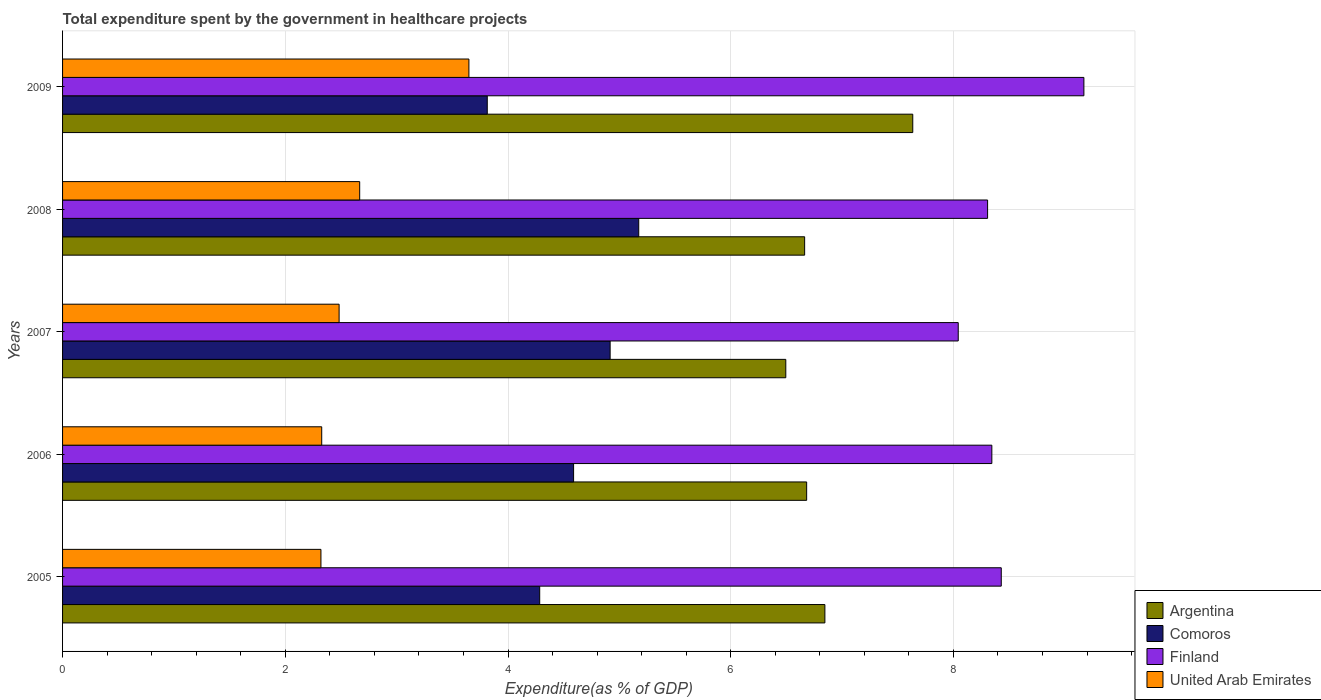How many different coloured bars are there?
Offer a very short reply. 4. How many groups of bars are there?
Offer a very short reply. 5. Are the number of bars per tick equal to the number of legend labels?
Your answer should be compact. Yes. Are the number of bars on each tick of the Y-axis equal?
Your response must be concise. Yes. What is the label of the 5th group of bars from the top?
Your answer should be very brief. 2005. What is the total expenditure spent by the government in healthcare projects in United Arab Emirates in 2006?
Your answer should be compact. 2.33. Across all years, what is the maximum total expenditure spent by the government in healthcare projects in Argentina?
Give a very brief answer. 7.63. Across all years, what is the minimum total expenditure spent by the government in healthcare projects in Comoros?
Make the answer very short. 3.81. In which year was the total expenditure spent by the government in healthcare projects in Finland minimum?
Keep it short and to the point. 2007. What is the total total expenditure spent by the government in healthcare projects in Argentina in the graph?
Give a very brief answer. 34.32. What is the difference between the total expenditure spent by the government in healthcare projects in United Arab Emirates in 2005 and that in 2008?
Offer a terse response. -0.35. What is the difference between the total expenditure spent by the government in healthcare projects in Argentina in 2009 and the total expenditure spent by the government in healthcare projects in United Arab Emirates in 2008?
Provide a succinct answer. 4.97. What is the average total expenditure spent by the government in healthcare projects in Comoros per year?
Provide a succinct answer. 4.56. In the year 2005, what is the difference between the total expenditure spent by the government in healthcare projects in Finland and total expenditure spent by the government in healthcare projects in Comoros?
Make the answer very short. 4.14. What is the ratio of the total expenditure spent by the government in healthcare projects in Finland in 2005 to that in 2008?
Offer a very short reply. 1.01. Is the total expenditure spent by the government in healthcare projects in Argentina in 2005 less than that in 2009?
Offer a very short reply. Yes. What is the difference between the highest and the second highest total expenditure spent by the government in healthcare projects in Argentina?
Your answer should be very brief. 0.79. What is the difference between the highest and the lowest total expenditure spent by the government in healthcare projects in Argentina?
Make the answer very short. 1.14. Is the sum of the total expenditure spent by the government in healthcare projects in Argentina in 2007 and 2008 greater than the maximum total expenditure spent by the government in healthcare projects in Comoros across all years?
Your response must be concise. Yes. Is it the case that in every year, the sum of the total expenditure spent by the government in healthcare projects in United Arab Emirates and total expenditure spent by the government in healthcare projects in Argentina is greater than the sum of total expenditure spent by the government in healthcare projects in Finland and total expenditure spent by the government in healthcare projects in Comoros?
Make the answer very short. Yes. Is it the case that in every year, the sum of the total expenditure spent by the government in healthcare projects in Argentina and total expenditure spent by the government in healthcare projects in Finland is greater than the total expenditure spent by the government in healthcare projects in Comoros?
Provide a succinct answer. Yes. How many years are there in the graph?
Give a very brief answer. 5. What is the difference between two consecutive major ticks on the X-axis?
Keep it short and to the point. 2. Are the values on the major ticks of X-axis written in scientific E-notation?
Your response must be concise. No. Does the graph contain grids?
Your answer should be compact. Yes. Where does the legend appear in the graph?
Keep it short and to the point. Bottom right. How many legend labels are there?
Offer a very short reply. 4. How are the legend labels stacked?
Your answer should be very brief. Vertical. What is the title of the graph?
Your answer should be very brief. Total expenditure spent by the government in healthcare projects. What is the label or title of the X-axis?
Provide a short and direct response. Expenditure(as % of GDP). What is the Expenditure(as % of GDP) in Argentina in 2005?
Your answer should be very brief. 6.85. What is the Expenditure(as % of GDP) of Comoros in 2005?
Keep it short and to the point. 4.28. What is the Expenditure(as % of GDP) in Finland in 2005?
Offer a terse response. 8.43. What is the Expenditure(as % of GDP) of United Arab Emirates in 2005?
Make the answer very short. 2.32. What is the Expenditure(as % of GDP) of Argentina in 2006?
Ensure brevity in your answer.  6.68. What is the Expenditure(as % of GDP) of Comoros in 2006?
Offer a very short reply. 4.59. What is the Expenditure(as % of GDP) in Finland in 2006?
Provide a succinct answer. 8.34. What is the Expenditure(as % of GDP) of United Arab Emirates in 2006?
Make the answer very short. 2.33. What is the Expenditure(as % of GDP) in Argentina in 2007?
Offer a terse response. 6.49. What is the Expenditure(as % of GDP) in Comoros in 2007?
Your response must be concise. 4.92. What is the Expenditure(as % of GDP) of Finland in 2007?
Provide a short and direct response. 8.04. What is the Expenditure(as % of GDP) of United Arab Emirates in 2007?
Provide a succinct answer. 2.48. What is the Expenditure(as % of GDP) in Argentina in 2008?
Your answer should be very brief. 6.66. What is the Expenditure(as % of GDP) of Comoros in 2008?
Offer a very short reply. 5.17. What is the Expenditure(as % of GDP) in Finland in 2008?
Offer a terse response. 8.31. What is the Expenditure(as % of GDP) of United Arab Emirates in 2008?
Make the answer very short. 2.67. What is the Expenditure(as % of GDP) in Argentina in 2009?
Your response must be concise. 7.63. What is the Expenditure(as % of GDP) in Comoros in 2009?
Provide a succinct answer. 3.81. What is the Expenditure(as % of GDP) of Finland in 2009?
Make the answer very short. 9.17. What is the Expenditure(as % of GDP) in United Arab Emirates in 2009?
Keep it short and to the point. 3.65. Across all years, what is the maximum Expenditure(as % of GDP) of Argentina?
Your answer should be very brief. 7.63. Across all years, what is the maximum Expenditure(as % of GDP) in Comoros?
Give a very brief answer. 5.17. Across all years, what is the maximum Expenditure(as % of GDP) in Finland?
Your response must be concise. 9.17. Across all years, what is the maximum Expenditure(as % of GDP) in United Arab Emirates?
Provide a succinct answer. 3.65. Across all years, what is the minimum Expenditure(as % of GDP) in Argentina?
Provide a short and direct response. 6.49. Across all years, what is the minimum Expenditure(as % of GDP) in Comoros?
Offer a very short reply. 3.81. Across all years, what is the minimum Expenditure(as % of GDP) of Finland?
Offer a terse response. 8.04. Across all years, what is the minimum Expenditure(as % of GDP) of United Arab Emirates?
Provide a short and direct response. 2.32. What is the total Expenditure(as % of GDP) of Argentina in the graph?
Make the answer very short. 34.32. What is the total Expenditure(as % of GDP) of Comoros in the graph?
Your answer should be very brief. 22.78. What is the total Expenditure(as % of GDP) of Finland in the graph?
Offer a terse response. 42.3. What is the total Expenditure(as % of GDP) in United Arab Emirates in the graph?
Offer a very short reply. 13.45. What is the difference between the Expenditure(as % of GDP) in Argentina in 2005 and that in 2006?
Provide a succinct answer. 0.16. What is the difference between the Expenditure(as % of GDP) of Comoros in 2005 and that in 2006?
Your response must be concise. -0.3. What is the difference between the Expenditure(as % of GDP) in Finland in 2005 and that in 2006?
Make the answer very short. 0.08. What is the difference between the Expenditure(as % of GDP) of United Arab Emirates in 2005 and that in 2006?
Offer a very short reply. -0.01. What is the difference between the Expenditure(as % of GDP) of Argentina in 2005 and that in 2007?
Your response must be concise. 0.35. What is the difference between the Expenditure(as % of GDP) in Comoros in 2005 and that in 2007?
Make the answer very short. -0.63. What is the difference between the Expenditure(as % of GDP) in Finland in 2005 and that in 2007?
Ensure brevity in your answer.  0.39. What is the difference between the Expenditure(as % of GDP) in United Arab Emirates in 2005 and that in 2007?
Your response must be concise. -0.16. What is the difference between the Expenditure(as % of GDP) of Argentina in 2005 and that in 2008?
Offer a terse response. 0.18. What is the difference between the Expenditure(as % of GDP) of Comoros in 2005 and that in 2008?
Give a very brief answer. -0.89. What is the difference between the Expenditure(as % of GDP) in Finland in 2005 and that in 2008?
Your response must be concise. 0.12. What is the difference between the Expenditure(as % of GDP) of United Arab Emirates in 2005 and that in 2008?
Your answer should be very brief. -0.35. What is the difference between the Expenditure(as % of GDP) of Argentina in 2005 and that in 2009?
Your answer should be compact. -0.79. What is the difference between the Expenditure(as % of GDP) in Comoros in 2005 and that in 2009?
Give a very brief answer. 0.47. What is the difference between the Expenditure(as % of GDP) of Finland in 2005 and that in 2009?
Give a very brief answer. -0.74. What is the difference between the Expenditure(as % of GDP) in United Arab Emirates in 2005 and that in 2009?
Offer a terse response. -1.33. What is the difference between the Expenditure(as % of GDP) of Argentina in 2006 and that in 2007?
Ensure brevity in your answer.  0.19. What is the difference between the Expenditure(as % of GDP) in Comoros in 2006 and that in 2007?
Ensure brevity in your answer.  -0.33. What is the difference between the Expenditure(as % of GDP) in Finland in 2006 and that in 2007?
Provide a short and direct response. 0.3. What is the difference between the Expenditure(as % of GDP) in United Arab Emirates in 2006 and that in 2007?
Your answer should be very brief. -0.16. What is the difference between the Expenditure(as % of GDP) in Argentina in 2006 and that in 2008?
Provide a succinct answer. 0.02. What is the difference between the Expenditure(as % of GDP) of Comoros in 2006 and that in 2008?
Your answer should be very brief. -0.58. What is the difference between the Expenditure(as % of GDP) of Finland in 2006 and that in 2008?
Provide a succinct answer. 0.04. What is the difference between the Expenditure(as % of GDP) of United Arab Emirates in 2006 and that in 2008?
Your answer should be compact. -0.34. What is the difference between the Expenditure(as % of GDP) in Argentina in 2006 and that in 2009?
Offer a very short reply. -0.95. What is the difference between the Expenditure(as % of GDP) of Comoros in 2006 and that in 2009?
Keep it short and to the point. 0.78. What is the difference between the Expenditure(as % of GDP) of Finland in 2006 and that in 2009?
Make the answer very short. -0.83. What is the difference between the Expenditure(as % of GDP) of United Arab Emirates in 2006 and that in 2009?
Give a very brief answer. -1.32. What is the difference between the Expenditure(as % of GDP) of Argentina in 2007 and that in 2008?
Keep it short and to the point. -0.17. What is the difference between the Expenditure(as % of GDP) in Comoros in 2007 and that in 2008?
Offer a very short reply. -0.26. What is the difference between the Expenditure(as % of GDP) in Finland in 2007 and that in 2008?
Provide a short and direct response. -0.26. What is the difference between the Expenditure(as % of GDP) in United Arab Emirates in 2007 and that in 2008?
Keep it short and to the point. -0.18. What is the difference between the Expenditure(as % of GDP) in Argentina in 2007 and that in 2009?
Your response must be concise. -1.14. What is the difference between the Expenditure(as % of GDP) in Comoros in 2007 and that in 2009?
Provide a succinct answer. 1.1. What is the difference between the Expenditure(as % of GDP) in Finland in 2007 and that in 2009?
Your answer should be compact. -1.13. What is the difference between the Expenditure(as % of GDP) of United Arab Emirates in 2007 and that in 2009?
Offer a terse response. -1.17. What is the difference between the Expenditure(as % of GDP) of Argentina in 2008 and that in 2009?
Give a very brief answer. -0.97. What is the difference between the Expenditure(as % of GDP) in Comoros in 2008 and that in 2009?
Ensure brevity in your answer.  1.36. What is the difference between the Expenditure(as % of GDP) in Finland in 2008 and that in 2009?
Provide a succinct answer. -0.86. What is the difference between the Expenditure(as % of GDP) in United Arab Emirates in 2008 and that in 2009?
Keep it short and to the point. -0.98. What is the difference between the Expenditure(as % of GDP) in Argentina in 2005 and the Expenditure(as % of GDP) in Comoros in 2006?
Ensure brevity in your answer.  2.26. What is the difference between the Expenditure(as % of GDP) of Argentina in 2005 and the Expenditure(as % of GDP) of Finland in 2006?
Give a very brief answer. -1.5. What is the difference between the Expenditure(as % of GDP) of Argentina in 2005 and the Expenditure(as % of GDP) of United Arab Emirates in 2006?
Keep it short and to the point. 4.52. What is the difference between the Expenditure(as % of GDP) of Comoros in 2005 and the Expenditure(as % of GDP) of Finland in 2006?
Your response must be concise. -4.06. What is the difference between the Expenditure(as % of GDP) in Comoros in 2005 and the Expenditure(as % of GDP) in United Arab Emirates in 2006?
Keep it short and to the point. 1.96. What is the difference between the Expenditure(as % of GDP) in Finland in 2005 and the Expenditure(as % of GDP) in United Arab Emirates in 2006?
Your response must be concise. 6.1. What is the difference between the Expenditure(as % of GDP) of Argentina in 2005 and the Expenditure(as % of GDP) of Comoros in 2007?
Ensure brevity in your answer.  1.93. What is the difference between the Expenditure(as % of GDP) of Argentina in 2005 and the Expenditure(as % of GDP) of Finland in 2007?
Give a very brief answer. -1.2. What is the difference between the Expenditure(as % of GDP) of Argentina in 2005 and the Expenditure(as % of GDP) of United Arab Emirates in 2007?
Ensure brevity in your answer.  4.36. What is the difference between the Expenditure(as % of GDP) in Comoros in 2005 and the Expenditure(as % of GDP) in Finland in 2007?
Ensure brevity in your answer.  -3.76. What is the difference between the Expenditure(as % of GDP) of Comoros in 2005 and the Expenditure(as % of GDP) of United Arab Emirates in 2007?
Your answer should be very brief. 1.8. What is the difference between the Expenditure(as % of GDP) in Finland in 2005 and the Expenditure(as % of GDP) in United Arab Emirates in 2007?
Provide a short and direct response. 5.95. What is the difference between the Expenditure(as % of GDP) in Argentina in 2005 and the Expenditure(as % of GDP) in Comoros in 2008?
Provide a succinct answer. 1.67. What is the difference between the Expenditure(as % of GDP) in Argentina in 2005 and the Expenditure(as % of GDP) in Finland in 2008?
Make the answer very short. -1.46. What is the difference between the Expenditure(as % of GDP) in Argentina in 2005 and the Expenditure(as % of GDP) in United Arab Emirates in 2008?
Provide a succinct answer. 4.18. What is the difference between the Expenditure(as % of GDP) of Comoros in 2005 and the Expenditure(as % of GDP) of Finland in 2008?
Offer a very short reply. -4.02. What is the difference between the Expenditure(as % of GDP) in Comoros in 2005 and the Expenditure(as % of GDP) in United Arab Emirates in 2008?
Offer a terse response. 1.62. What is the difference between the Expenditure(as % of GDP) of Finland in 2005 and the Expenditure(as % of GDP) of United Arab Emirates in 2008?
Give a very brief answer. 5.76. What is the difference between the Expenditure(as % of GDP) in Argentina in 2005 and the Expenditure(as % of GDP) in Comoros in 2009?
Provide a short and direct response. 3.03. What is the difference between the Expenditure(as % of GDP) of Argentina in 2005 and the Expenditure(as % of GDP) of Finland in 2009?
Your response must be concise. -2.33. What is the difference between the Expenditure(as % of GDP) in Argentina in 2005 and the Expenditure(as % of GDP) in United Arab Emirates in 2009?
Your answer should be very brief. 3.2. What is the difference between the Expenditure(as % of GDP) in Comoros in 2005 and the Expenditure(as % of GDP) in Finland in 2009?
Provide a short and direct response. -4.89. What is the difference between the Expenditure(as % of GDP) in Comoros in 2005 and the Expenditure(as % of GDP) in United Arab Emirates in 2009?
Your answer should be very brief. 0.64. What is the difference between the Expenditure(as % of GDP) in Finland in 2005 and the Expenditure(as % of GDP) in United Arab Emirates in 2009?
Ensure brevity in your answer.  4.78. What is the difference between the Expenditure(as % of GDP) of Argentina in 2006 and the Expenditure(as % of GDP) of Comoros in 2007?
Your answer should be compact. 1.76. What is the difference between the Expenditure(as % of GDP) in Argentina in 2006 and the Expenditure(as % of GDP) in Finland in 2007?
Give a very brief answer. -1.36. What is the difference between the Expenditure(as % of GDP) of Argentina in 2006 and the Expenditure(as % of GDP) of United Arab Emirates in 2007?
Give a very brief answer. 4.2. What is the difference between the Expenditure(as % of GDP) of Comoros in 2006 and the Expenditure(as % of GDP) of Finland in 2007?
Give a very brief answer. -3.45. What is the difference between the Expenditure(as % of GDP) of Comoros in 2006 and the Expenditure(as % of GDP) of United Arab Emirates in 2007?
Your answer should be compact. 2.11. What is the difference between the Expenditure(as % of GDP) of Finland in 2006 and the Expenditure(as % of GDP) of United Arab Emirates in 2007?
Your response must be concise. 5.86. What is the difference between the Expenditure(as % of GDP) of Argentina in 2006 and the Expenditure(as % of GDP) of Comoros in 2008?
Offer a terse response. 1.51. What is the difference between the Expenditure(as % of GDP) of Argentina in 2006 and the Expenditure(as % of GDP) of Finland in 2008?
Your answer should be compact. -1.62. What is the difference between the Expenditure(as % of GDP) in Argentina in 2006 and the Expenditure(as % of GDP) in United Arab Emirates in 2008?
Offer a very short reply. 4.01. What is the difference between the Expenditure(as % of GDP) in Comoros in 2006 and the Expenditure(as % of GDP) in Finland in 2008?
Your answer should be compact. -3.72. What is the difference between the Expenditure(as % of GDP) of Comoros in 2006 and the Expenditure(as % of GDP) of United Arab Emirates in 2008?
Give a very brief answer. 1.92. What is the difference between the Expenditure(as % of GDP) of Finland in 2006 and the Expenditure(as % of GDP) of United Arab Emirates in 2008?
Ensure brevity in your answer.  5.68. What is the difference between the Expenditure(as % of GDP) in Argentina in 2006 and the Expenditure(as % of GDP) in Comoros in 2009?
Provide a short and direct response. 2.87. What is the difference between the Expenditure(as % of GDP) in Argentina in 2006 and the Expenditure(as % of GDP) in Finland in 2009?
Your response must be concise. -2.49. What is the difference between the Expenditure(as % of GDP) in Argentina in 2006 and the Expenditure(as % of GDP) in United Arab Emirates in 2009?
Make the answer very short. 3.03. What is the difference between the Expenditure(as % of GDP) in Comoros in 2006 and the Expenditure(as % of GDP) in Finland in 2009?
Offer a very short reply. -4.58. What is the difference between the Expenditure(as % of GDP) in Comoros in 2006 and the Expenditure(as % of GDP) in United Arab Emirates in 2009?
Offer a very short reply. 0.94. What is the difference between the Expenditure(as % of GDP) in Finland in 2006 and the Expenditure(as % of GDP) in United Arab Emirates in 2009?
Provide a succinct answer. 4.7. What is the difference between the Expenditure(as % of GDP) in Argentina in 2007 and the Expenditure(as % of GDP) in Comoros in 2008?
Make the answer very short. 1.32. What is the difference between the Expenditure(as % of GDP) in Argentina in 2007 and the Expenditure(as % of GDP) in Finland in 2008?
Your response must be concise. -1.81. What is the difference between the Expenditure(as % of GDP) in Argentina in 2007 and the Expenditure(as % of GDP) in United Arab Emirates in 2008?
Your answer should be compact. 3.83. What is the difference between the Expenditure(as % of GDP) of Comoros in 2007 and the Expenditure(as % of GDP) of Finland in 2008?
Your answer should be compact. -3.39. What is the difference between the Expenditure(as % of GDP) in Comoros in 2007 and the Expenditure(as % of GDP) in United Arab Emirates in 2008?
Offer a terse response. 2.25. What is the difference between the Expenditure(as % of GDP) in Finland in 2007 and the Expenditure(as % of GDP) in United Arab Emirates in 2008?
Your answer should be very brief. 5.37. What is the difference between the Expenditure(as % of GDP) of Argentina in 2007 and the Expenditure(as % of GDP) of Comoros in 2009?
Keep it short and to the point. 2.68. What is the difference between the Expenditure(as % of GDP) in Argentina in 2007 and the Expenditure(as % of GDP) in Finland in 2009?
Ensure brevity in your answer.  -2.68. What is the difference between the Expenditure(as % of GDP) in Argentina in 2007 and the Expenditure(as % of GDP) in United Arab Emirates in 2009?
Your answer should be compact. 2.85. What is the difference between the Expenditure(as % of GDP) in Comoros in 2007 and the Expenditure(as % of GDP) in Finland in 2009?
Keep it short and to the point. -4.25. What is the difference between the Expenditure(as % of GDP) in Comoros in 2007 and the Expenditure(as % of GDP) in United Arab Emirates in 2009?
Offer a terse response. 1.27. What is the difference between the Expenditure(as % of GDP) in Finland in 2007 and the Expenditure(as % of GDP) in United Arab Emirates in 2009?
Your answer should be compact. 4.39. What is the difference between the Expenditure(as % of GDP) in Argentina in 2008 and the Expenditure(as % of GDP) in Comoros in 2009?
Provide a short and direct response. 2.85. What is the difference between the Expenditure(as % of GDP) of Argentina in 2008 and the Expenditure(as % of GDP) of Finland in 2009?
Keep it short and to the point. -2.51. What is the difference between the Expenditure(as % of GDP) of Argentina in 2008 and the Expenditure(as % of GDP) of United Arab Emirates in 2009?
Your answer should be very brief. 3.01. What is the difference between the Expenditure(as % of GDP) in Comoros in 2008 and the Expenditure(as % of GDP) in Finland in 2009?
Your answer should be compact. -4. What is the difference between the Expenditure(as % of GDP) in Comoros in 2008 and the Expenditure(as % of GDP) in United Arab Emirates in 2009?
Offer a terse response. 1.53. What is the difference between the Expenditure(as % of GDP) in Finland in 2008 and the Expenditure(as % of GDP) in United Arab Emirates in 2009?
Ensure brevity in your answer.  4.66. What is the average Expenditure(as % of GDP) of Argentina per year?
Your answer should be very brief. 6.86. What is the average Expenditure(as % of GDP) in Comoros per year?
Offer a very short reply. 4.56. What is the average Expenditure(as % of GDP) of Finland per year?
Give a very brief answer. 8.46. What is the average Expenditure(as % of GDP) of United Arab Emirates per year?
Offer a very short reply. 2.69. In the year 2005, what is the difference between the Expenditure(as % of GDP) in Argentina and Expenditure(as % of GDP) in Comoros?
Your answer should be very brief. 2.56. In the year 2005, what is the difference between the Expenditure(as % of GDP) of Argentina and Expenditure(as % of GDP) of Finland?
Make the answer very short. -1.58. In the year 2005, what is the difference between the Expenditure(as % of GDP) of Argentina and Expenditure(as % of GDP) of United Arab Emirates?
Give a very brief answer. 4.53. In the year 2005, what is the difference between the Expenditure(as % of GDP) of Comoros and Expenditure(as % of GDP) of Finland?
Keep it short and to the point. -4.14. In the year 2005, what is the difference between the Expenditure(as % of GDP) of Comoros and Expenditure(as % of GDP) of United Arab Emirates?
Offer a terse response. 1.96. In the year 2005, what is the difference between the Expenditure(as % of GDP) of Finland and Expenditure(as % of GDP) of United Arab Emirates?
Offer a terse response. 6.11. In the year 2006, what is the difference between the Expenditure(as % of GDP) in Argentina and Expenditure(as % of GDP) in Comoros?
Make the answer very short. 2.09. In the year 2006, what is the difference between the Expenditure(as % of GDP) in Argentina and Expenditure(as % of GDP) in Finland?
Your answer should be compact. -1.66. In the year 2006, what is the difference between the Expenditure(as % of GDP) of Argentina and Expenditure(as % of GDP) of United Arab Emirates?
Make the answer very short. 4.35. In the year 2006, what is the difference between the Expenditure(as % of GDP) of Comoros and Expenditure(as % of GDP) of Finland?
Provide a short and direct response. -3.76. In the year 2006, what is the difference between the Expenditure(as % of GDP) in Comoros and Expenditure(as % of GDP) in United Arab Emirates?
Offer a very short reply. 2.26. In the year 2006, what is the difference between the Expenditure(as % of GDP) in Finland and Expenditure(as % of GDP) in United Arab Emirates?
Your answer should be very brief. 6.02. In the year 2007, what is the difference between the Expenditure(as % of GDP) in Argentina and Expenditure(as % of GDP) in Comoros?
Your response must be concise. 1.58. In the year 2007, what is the difference between the Expenditure(as % of GDP) in Argentina and Expenditure(as % of GDP) in Finland?
Offer a terse response. -1.55. In the year 2007, what is the difference between the Expenditure(as % of GDP) of Argentina and Expenditure(as % of GDP) of United Arab Emirates?
Give a very brief answer. 4.01. In the year 2007, what is the difference between the Expenditure(as % of GDP) in Comoros and Expenditure(as % of GDP) in Finland?
Provide a succinct answer. -3.13. In the year 2007, what is the difference between the Expenditure(as % of GDP) of Comoros and Expenditure(as % of GDP) of United Arab Emirates?
Make the answer very short. 2.43. In the year 2007, what is the difference between the Expenditure(as % of GDP) of Finland and Expenditure(as % of GDP) of United Arab Emirates?
Ensure brevity in your answer.  5.56. In the year 2008, what is the difference between the Expenditure(as % of GDP) in Argentina and Expenditure(as % of GDP) in Comoros?
Give a very brief answer. 1.49. In the year 2008, what is the difference between the Expenditure(as % of GDP) of Argentina and Expenditure(as % of GDP) of Finland?
Your answer should be compact. -1.64. In the year 2008, what is the difference between the Expenditure(as % of GDP) of Argentina and Expenditure(as % of GDP) of United Arab Emirates?
Offer a terse response. 4. In the year 2008, what is the difference between the Expenditure(as % of GDP) of Comoros and Expenditure(as % of GDP) of Finland?
Make the answer very short. -3.13. In the year 2008, what is the difference between the Expenditure(as % of GDP) of Comoros and Expenditure(as % of GDP) of United Arab Emirates?
Your answer should be very brief. 2.51. In the year 2008, what is the difference between the Expenditure(as % of GDP) in Finland and Expenditure(as % of GDP) in United Arab Emirates?
Provide a short and direct response. 5.64. In the year 2009, what is the difference between the Expenditure(as % of GDP) in Argentina and Expenditure(as % of GDP) in Comoros?
Your answer should be very brief. 3.82. In the year 2009, what is the difference between the Expenditure(as % of GDP) in Argentina and Expenditure(as % of GDP) in Finland?
Offer a very short reply. -1.54. In the year 2009, what is the difference between the Expenditure(as % of GDP) in Argentina and Expenditure(as % of GDP) in United Arab Emirates?
Provide a succinct answer. 3.99. In the year 2009, what is the difference between the Expenditure(as % of GDP) of Comoros and Expenditure(as % of GDP) of Finland?
Provide a short and direct response. -5.36. In the year 2009, what is the difference between the Expenditure(as % of GDP) in Comoros and Expenditure(as % of GDP) in United Arab Emirates?
Offer a terse response. 0.17. In the year 2009, what is the difference between the Expenditure(as % of GDP) in Finland and Expenditure(as % of GDP) in United Arab Emirates?
Your answer should be compact. 5.52. What is the ratio of the Expenditure(as % of GDP) in Argentina in 2005 to that in 2006?
Provide a short and direct response. 1.02. What is the ratio of the Expenditure(as % of GDP) in Comoros in 2005 to that in 2006?
Offer a very short reply. 0.93. What is the ratio of the Expenditure(as % of GDP) of Argentina in 2005 to that in 2007?
Your answer should be compact. 1.05. What is the ratio of the Expenditure(as % of GDP) in Comoros in 2005 to that in 2007?
Offer a terse response. 0.87. What is the ratio of the Expenditure(as % of GDP) of Finland in 2005 to that in 2007?
Ensure brevity in your answer.  1.05. What is the ratio of the Expenditure(as % of GDP) of United Arab Emirates in 2005 to that in 2007?
Offer a terse response. 0.93. What is the ratio of the Expenditure(as % of GDP) of Argentina in 2005 to that in 2008?
Your answer should be compact. 1.03. What is the ratio of the Expenditure(as % of GDP) in Comoros in 2005 to that in 2008?
Your response must be concise. 0.83. What is the ratio of the Expenditure(as % of GDP) in Finland in 2005 to that in 2008?
Keep it short and to the point. 1.01. What is the ratio of the Expenditure(as % of GDP) in United Arab Emirates in 2005 to that in 2008?
Ensure brevity in your answer.  0.87. What is the ratio of the Expenditure(as % of GDP) of Argentina in 2005 to that in 2009?
Keep it short and to the point. 0.9. What is the ratio of the Expenditure(as % of GDP) of Comoros in 2005 to that in 2009?
Keep it short and to the point. 1.12. What is the ratio of the Expenditure(as % of GDP) of Finland in 2005 to that in 2009?
Your answer should be compact. 0.92. What is the ratio of the Expenditure(as % of GDP) of United Arab Emirates in 2005 to that in 2009?
Provide a succinct answer. 0.64. What is the ratio of the Expenditure(as % of GDP) of Argentina in 2006 to that in 2007?
Your answer should be compact. 1.03. What is the ratio of the Expenditure(as % of GDP) in Comoros in 2006 to that in 2007?
Offer a terse response. 0.93. What is the ratio of the Expenditure(as % of GDP) of Finland in 2006 to that in 2007?
Give a very brief answer. 1.04. What is the ratio of the Expenditure(as % of GDP) of United Arab Emirates in 2006 to that in 2007?
Keep it short and to the point. 0.94. What is the ratio of the Expenditure(as % of GDP) of Argentina in 2006 to that in 2008?
Your answer should be very brief. 1. What is the ratio of the Expenditure(as % of GDP) of Comoros in 2006 to that in 2008?
Provide a short and direct response. 0.89. What is the ratio of the Expenditure(as % of GDP) in United Arab Emirates in 2006 to that in 2008?
Provide a succinct answer. 0.87. What is the ratio of the Expenditure(as % of GDP) in Argentina in 2006 to that in 2009?
Offer a very short reply. 0.88. What is the ratio of the Expenditure(as % of GDP) in Comoros in 2006 to that in 2009?
Offer a terse response. 1.2. What is the ratio of the Expenditure(as % of GDP) of Finland in 2006 to that in 2009?
Keep it short and to the point. 0.91. What is the ratio of the Expenditure(as % of GDP) in United Arab Emirates in 2006 to that in 2009?
Give a very brief answer. 0.64. What is the ratio of the Expenditure(as % of GDP) in Argentina in 2007 to that in 2008?
Make the answer very short. 0.97. What is the ratio of the Expenditure(as % of GDP) in Comoros in 2007 to that in 2008?
Keep it short and to the point. 0.95. What is the ratio of the Expenditure(as % of GDP) in Finland in 2007 to that in 2008?
Provide a short and direct response. 0.97. What is the ratio of the Expenditure(as % of GDP) of United Arab Emirates in 2007 to that in 2008?
Offer a very short reply. 0.93. What is the ratio of the Expenditure(as % of GDP) in Argentina in 2007 to that in 2009?
Provide a succinct answer. 0.85. What is the ratio of the Expenditure(as % of GDP) in Comoros in 2007 to that in 2009?
Offer a very short reply. 1.29. What is the ratio of the Expenditure(as % of GDP) of Finland in 2007 to that in 2009?
Offer a very short reply. 0.88. What is the ratio of the Expenditure(as % of GDP) of United Arab Emirates in 2007 to that in 2009?
Your answer should be very brief. 0.68. What is the ratio of the Expenditure(as % of GDP) of Argentina in 2008 to that in 2009?
Keep it short and to the point. 0.87. What is the ratio of the Expenditure(as % of GDP) in Comoros in 2008 to that in 2009?
Keep it short and to the point. 1.36. What is the ratio of the Expenditure(as % of GDP) in Finland in 2008 to that in 2009?
Your answer should be compact. 0.91. What is the ratio of the Expenditure(as % of GDP) of United Arab Emirates in 2008 to that in 2009?
Give a very brief answer. 0.73. What is the difference between the highest and the second highest Expenditure(as % of GDP) of Argentina?
Your answer should be compact. 0.79. What is the difference between the highest and the second highest Expenditure(as % of GDP) in Comoros?
Offer a very short reply. 0.26. What is the difference between the highest and the second highest Expenditure(as % of GDP) of Finland?
Your answer should be compact. 0.74. What is the difference between the highest and the second highest Expenditure(as % of GDP) of United Arab Emirates?
Your answer should be very brief. 0.98. What is the difference between the highest and the lowest Expenditure(as % of GDP) in Argentina?
Give a very brief answer. 1.14. What is the difference between the highest and the lowest Expenditure(as % of GDP) in Comoros?
Offer a terse response. 1.36. What is the difference between the highest and the lowest Expenditure(as % of GDP) in Finland?
Your answer should be compact. 1.13. What is the difference between the highest and the lowest Expenditure(as % of GDP) of United Arab Emirates?
Your answer should be compact. 1.33. 